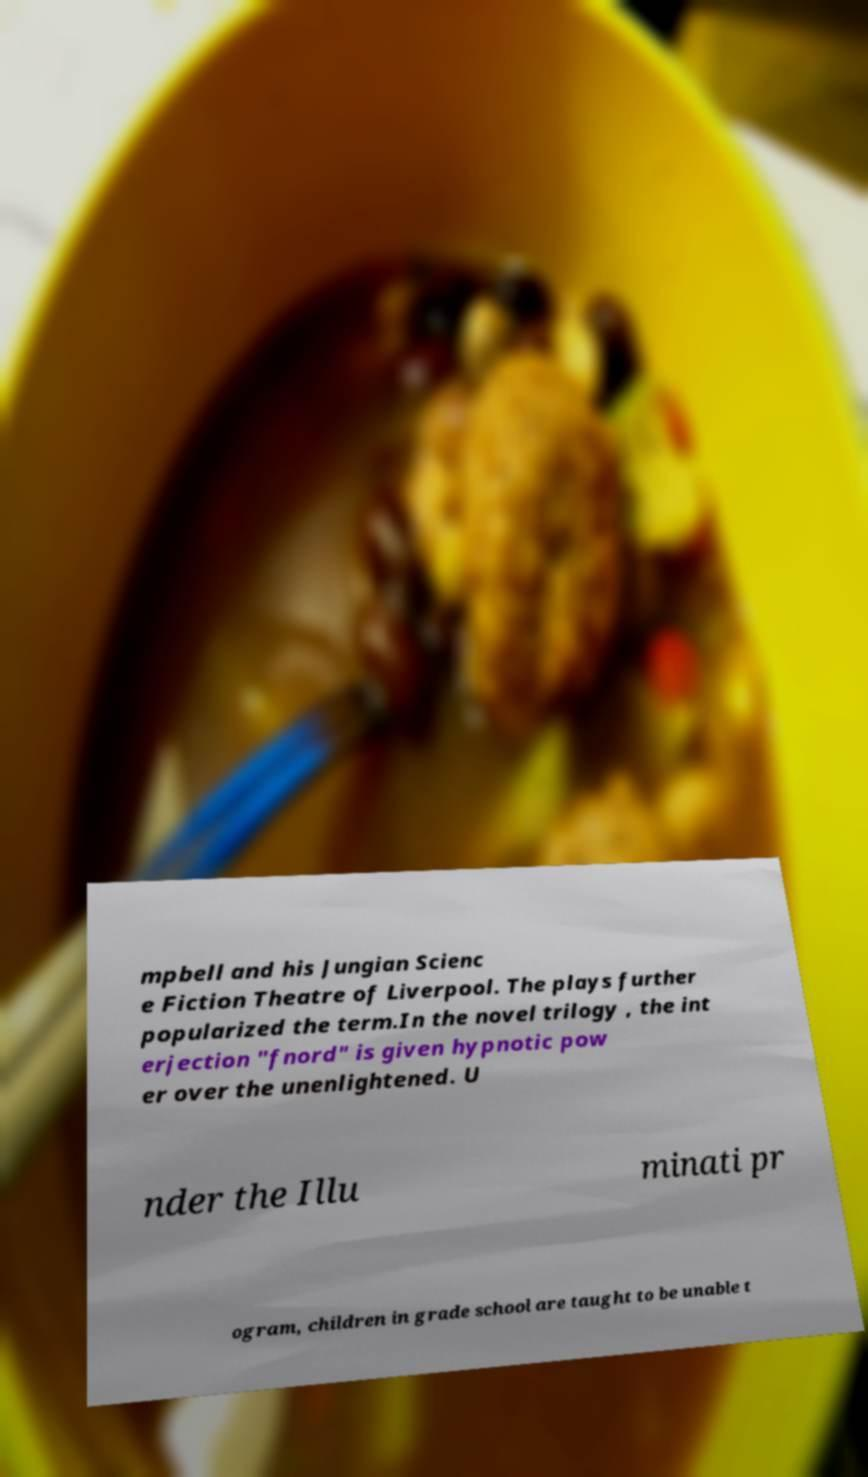Could you assist in decoding the text presented in this image and type it out clearly? mpbell and his Jungian Scienc e Fiction Theatre of Liverpool. The plays further popularized the term.In the novel trilogy , the int erjection "fnord" is given hypnotic pow er over the unenlightened. U nder the Illu minati pr ogram, children in grade school are taught to be unable t 